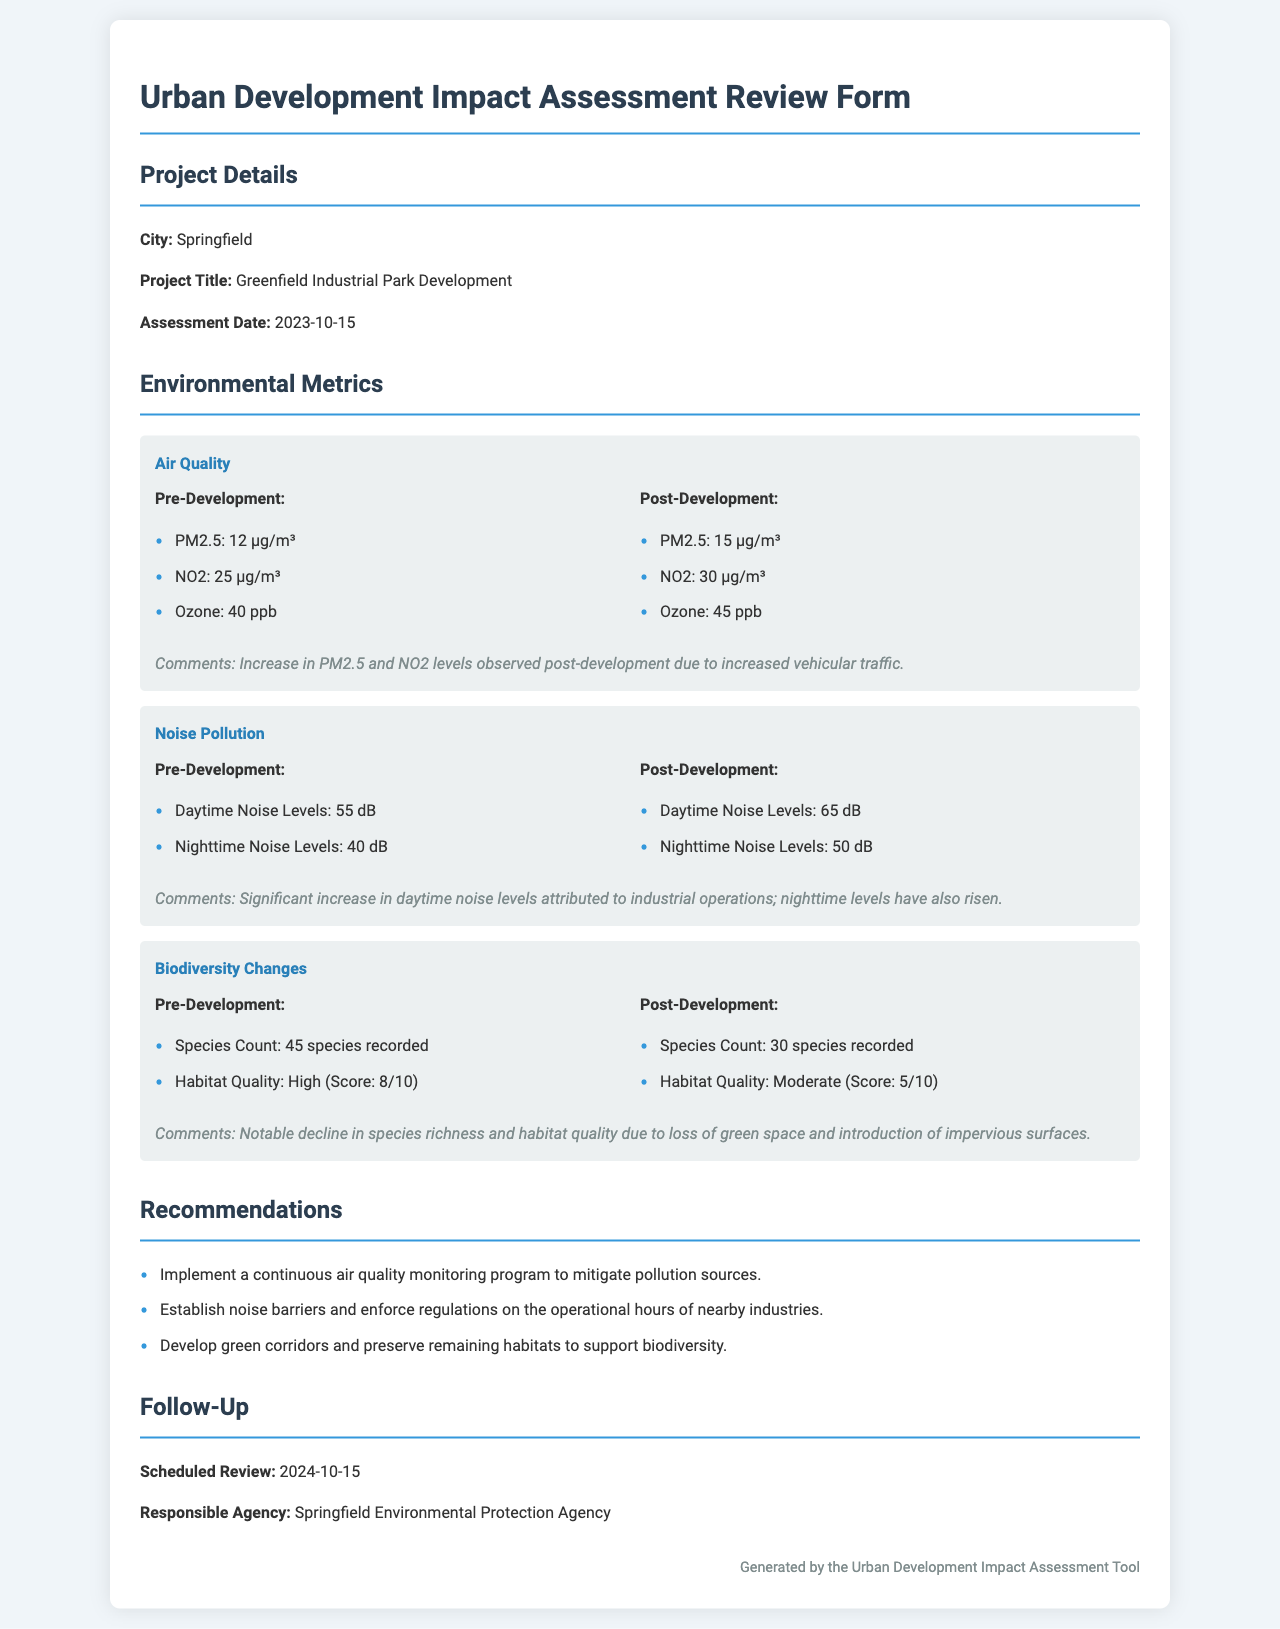what is the project title? The project title is stated in the document under Project Details.
Answer: Greenfield Industrial Park Development when was the assessment date? The assessment date is found in the Project Details section.
Answer: 2023-10-15 what is the PM2.5 level post-development? The PM2.5 level is noted under Air Quality pre- and post-development data.
Answer: 15 µg/m³ how many species were recorded pre-development? The species count is listed under Biodiversity Changes pre-development metrics.
Answer: 45 species recorded what is the habitat quality score post-development? The habitat quality score is mentioned in the Biodiversity Changes section.
Answer: 5/10 what caused the increase in PM2.5 and NO2 levels? The comments in the Air Quality section provide insight into the reason for the increase.
Answer: Increased vehicular traffic which agency is responsible for follow-up? The document specifies the responsible agency in the Follow-Up section.
Answer: Springfield Environmental Protection Agency how much did daytime noise levels increase after development? The comparison of daytime noise levels pre- and post-development provides the answer.
Answer: 10 dB what is one recommendation provided in the document? The Recommendations section lists suggestions for mitigating the project's impact.
Answer: Implement a continuous air quality monitoring program to mitigate pollution sources 